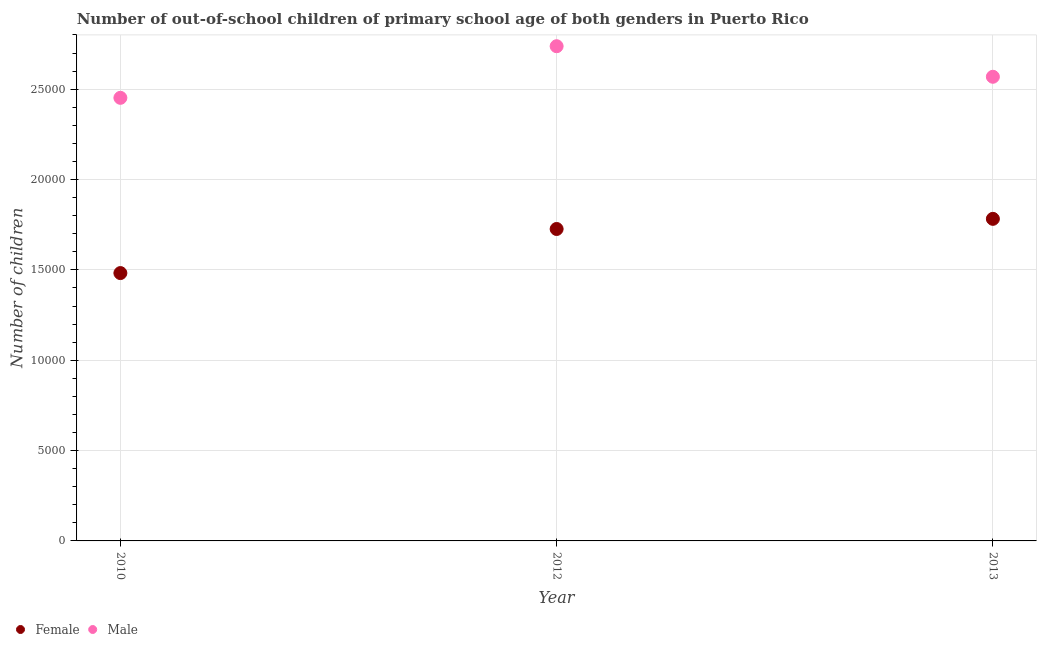Is the number of dotlines equal to the number of legend labels?
Ensure brevity in your answer.  Yes. What is the number of female out-of-school students in 2013?
Your response must be concise. 1.78e+04. Across all years, what is the maximum number of male out-of-school students?
Provide a short and direct response. 2.74e+04. Across all years, what is the minimum number of male out-of-school students?
Provide a short and direct response. 2.45e+04. In which year was the number of male out-of-school students maximum?
Offer a terse response. 2012. In which year was the number of female out-of-school students minimum?
Your answer should be compact. 2010. What is the total number of male out-of-school students in the graph?
Offer a terse response. 7.76e+04. What is the difference between the number of male out-of-school students in 2010 and that in 2012?
Provide a succinct answer. -2856. What is the difference between the number of male out-of-school students in 2010 and the number of female out-of-school students in 2012?
Your response must be concise. 7258. What is the average number of male out-of-school students per year?
Your response must be concise. 2.59e+04. In the year 2013, what is the difference between the number of male out-of-school students and number of female out-of-school students?
Provide a short and direct response. 7862. In how many years, is the number of female out-of-school students greater than 2000?
Your answer should be very brief. 3. What is the ratio of the number of female out-of-school students in 2010 to that in 2012?
Offer a very short reply. 0.86. Is the difference between the number of female out-of-school students in 2012 and 2013 greater than the difference between the number of male out-of-school students in 2012 and 2013?
Provide a succinct answer. No. What is the difference between the highest and the second highest number of female out-of-school students?
Your response must be concise. 561. What is the difference between the highest and the lowest number of female out-of-school students?
Provide a succinct answer. 3001. Does the number of male out-of-school students monotonically increase over the years?
Give a very brief answer. No. Is the number of male out-of-school students strictly less than the number of female out-of-school students over the years?
Give a very brief answer. No. How many dotlines are there?
Offer a very short reply. 2. How many years are there in the graph?
Give a very brief answer. 3. Does the graph contain grids?
Your answer should be very brief. Yes. What is the title of the graph?
Provide a succinct answer. Number of out-of-school children of primary school age of both genders in Puerto Rico. What is the label or title of the X-axis?
Give a very brief answer. Year. What is the label or title of the Y-axis?
Offer a very short reply. Number of children. What is the Number of children in Female in 2010?
Your response must be concise. 1.48e+04. What is the Number of children of Male in 2010?
Give a very brief answer. 2.45e+04. What is the Number of children of Female in 2012?
Provide a succinct answer. 1.73e+04. What is the Number of children in Male in 2012?
Make the answer very short. 2.74e+04. What is the Number of children in Female in 2013?
Keep it short and to the point. 1.78e+04. What is the Number of children in Male in 2013?
Provide a succinct answer. 2.57e+04. Across all years, what is the maximum Number of children in Female?
Your answer should be very brief. 1.78e+04. Across all years, what is the maximum Number of children in Male?
Make the answer very short. 2.74e+04. Across all years, what is the minimum Number of children of Female?
Give a very brief answer. 1.48e+04. Across all years, what is the minimum Number of children of Male?
Your answer should be compact. 2.45e+04. What is the total Number of children in Female in the graph?
Your answer should be compact. 4.99e+04. What is the total Number of children in Male in the graph?
Your response must be concise. 7.76e+04. What is the difference between the Number of children of Female in 2010 and that in 2012?
Give a very brief answer. -2440. What is the difference between the Number of children in Male in 2010 and that in 2012?
Your response must be concise. -2856. What is the difference between the Number of children in Female in 2010 and that in 2013?
Your answer should be very brief. -3001. What is the difference between the Number of children of Male in 2010 and that in 2013?
Keep it short and to the point. -1165. What is the difference between the Number of children in Female in 2012 and that in 2013?
Keep it short and to the point. -561. What is the difference between the Number of children of Male in 2012 and that in 2013?
Keep it short and to the point. 1691. What is the difference between the Number of children in Female in 2010 and the Number of children in Male in 2012?
Ensure brevity in your answer.  -1.26e+04. What is the difference between the Number of children in Female in 2010 and the Number of children in Male in 2013?
Ensure brevity in your answer.  -1.09e+04. What is the difference between the Number of children in Female in 2012 and the Number of children in Male in 2013?
Give a very brief answer. -8423. What is the average Number of children of Female per year?
Ensure brevity in your answer.  1.66e+04. What is the average Number of children of Male per year?
Your answer should be compact. 2.59e+04. In the year 2010, what is the difference between the Number of children of Female and Number of children of Male?
Your response must be concise. -9698. In the year 2012, what is the difference between the Number of children in Female and Number of children in Male?
Give a very brief answer. -1.01e+04. In the year 2013, what is the difference between the Number of children of Female and Number of children of Male?
Provide a succinct answer. -7862. What is the ratio of the Number of children in Female in 2010 to that in 2012?
Make the answer very short. 0.86. What is the ratio of the Number of children in Male in 2010 to that in 2012?
Your answer should be compact. 0.9. What is the ratio of the Number of children in Female in 2010 to that in 2013?
Ensure brevity in your answer.  0.83. What is the ratio of the Number of children of Male in 2010 to that in 2013?
Offer a very short reply. 0.95. What is the ratio of the Number of children in Female in 2012 to that in 2013?
Your answer should be compact. 0.97. What is the ratio of the Number of children of Male in 2012 to that in 2013?
Your answer should be compact. 1.07. What is the difference between the highest and the second highest Number of children of Female?
Make the answer very short. 561. What is the difference between the highest and the second highest Number of children in Male?
Give a very brief answer. 1691. What is the difference between the highest and the lowest Number of children of Female?
Give a very brief answer. 3001. What is the difference between the highest and the lowest Number of children of Male?
Give a very brief answer. 2856. 